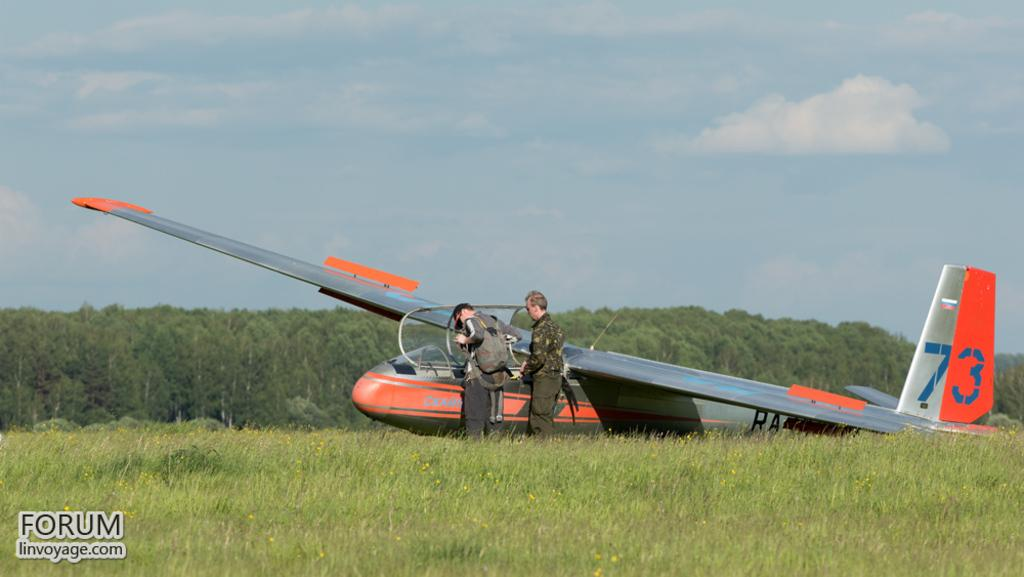Provide a one-sentence caption for the provided image. A plane numbered 73 sits on the ground with two people in front of it. 